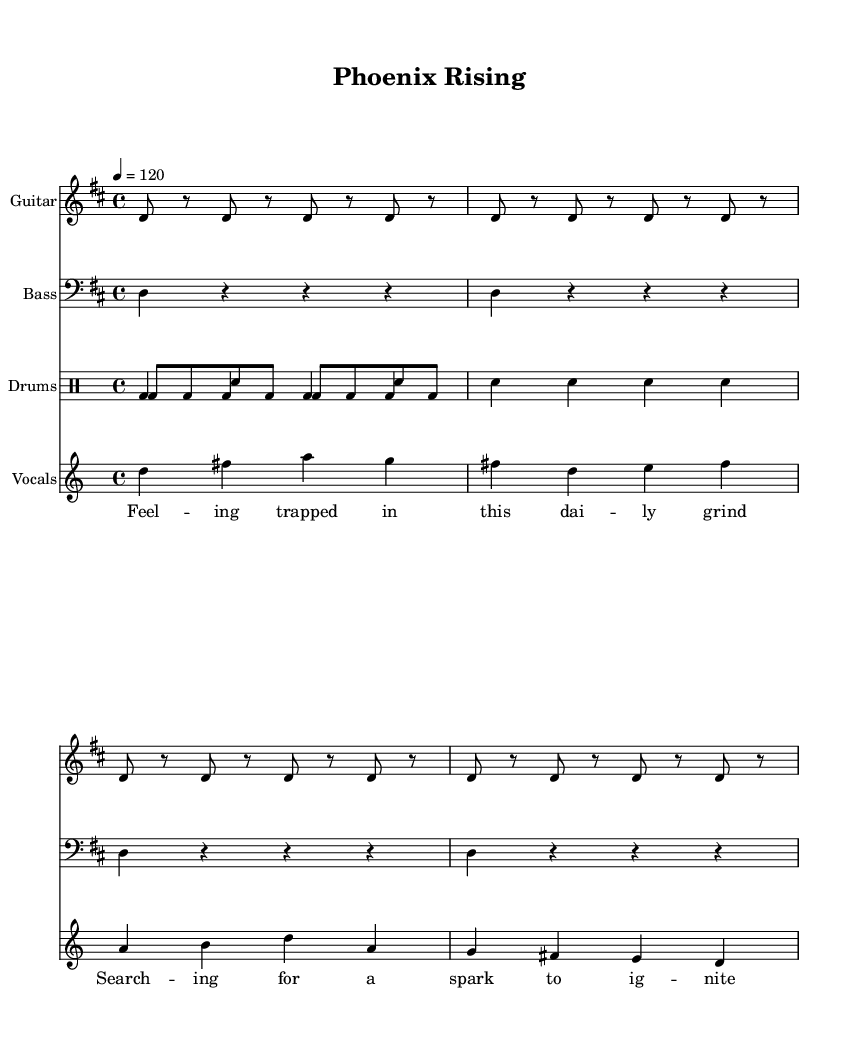What is the key signature of this music? The key signature of the piece is D major, which has two sharps (F# and C#). This is identified in the global section where it indicates "\key d \major".
Answer: D major What is the time signature of this music? The time signature is indicated in the global section with "\time 4/4". This means there are four beats in a measure, and each quarter note gets one beat.
Answer: 4/4 What tempo is indicated for this music? The tempo markings are found in the global settings where it states "\tempo 4 = 120", meaning the quarter note should be played at 120 beats per minute.
Answer: 120 What is the main theme expressed in the vocal lyrics? The lyrics speak about overcoming challenges and rising up, evident in phrases like "I'm rising up, like a phoenix from the flame" which suggest themes of resilience and empowerment.
Answer: Overcoming challenges What instrument plays a repeated rhythmic pattern in the drum section? The drum section features a bass drum that plays a consistent pattern. This is shown in the drummode where "bd" represents the bass drum, repeated throughout the measures.
Answer: Bass drum How does the chorus differ musically from the verse? In the chorus, the notes are higher in pitch compared to the verse, indicating a lift in emotional energy. This is noted by the increase in musical intervals, moving from a more grounded sound in the verse to a more uplifting sound in the chorus.
Answer: Higher pitch 